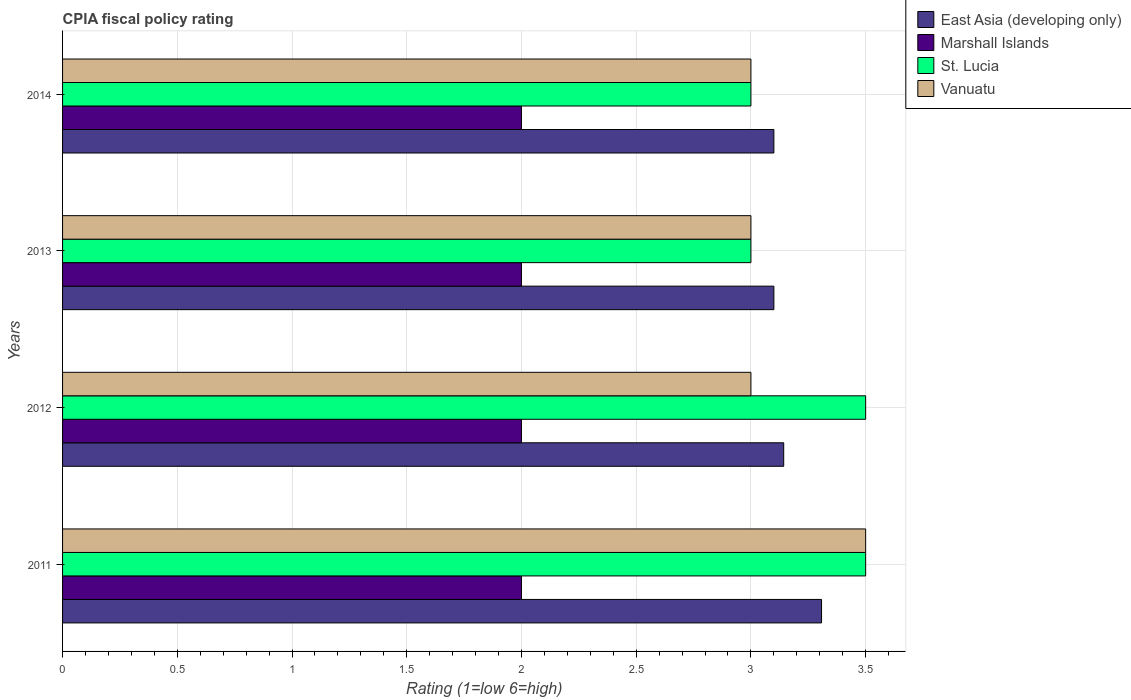How many groups of bars are there?
Your answer should be compact. 4. How many bars are there on the 2nd tick from the bottom?
Provide a short and direct response. 4. What is the label of the 1st group of bars from the top?
Your response must be concise. 2014. Across all years, what is the maximum CPIA rating in Vanuatu?
Your answer should be compact. 3.5. In which year was the CPIA rating in East Asia (developing only) maximum?
Offer a very short reply. 2011. What is the total CPIA rating in Vanuatu in the graph?
Make the answer very short. 12.5. What is the difference between the CPIA rating in Marshall Islands in 2013 and that in 2014?
Your response must be concise. 0. What is the average CPIA rating in East Asia (developing only) per year?
Provide a succinct answer. 3.16. In how many years, is the CPIA rating in East Asia (developing only) greater than 0.8 ?
Your answer should be very brief. 4. What is the ratio of the CPIA rating in St. Lucia in 2012 to that in 2014?
Your answer should be compact. 1.17. Is the CPIA rating in St. Lucia in 2011 less than that in 2013?
Give a very brief answer. No. Is the difference between the CPIA rating in Marshall Islands in 2012 and 2014 greater than the difference between the CPIA rating in Vanuatu in 2012 and 2014?
Keep it short and to the point. No. Is the sum of the CPIA rating in East Asia (developing only) in 2013 and 2014 greater than the maximum CPIA rating in Marshall Islands across all years?
Keep it short and to the point. Yes. Is it the case that in every year, the sum of the CPIA rating in East Asia (developing only) and CPIA rating in St. Lucia is greater than the sum of CPIA rating in Vanuatu and CPIA rating in Marshall Islands?
Provide a short and direct response. Yes. What does the 1st bar from the top in 2012 represents?
Your response must be concise. Vanuatu. What does the 4th bar from the bottom in 2014 represents?
Provide a short and direct response. Vanuatu. Is it the case that in every year, the sum of the CPIA rating in Marshall Islands and CPIA rating in East Asia (developing only) is greater than the CPIA rating in Vanuatu?
Offer a very short reply. Yes. How many bars are there?
Ensure brevity in your answer.  16. Are all the bars in the graph horizontal?
Make the answer very short. Yes. What is the difference between two consecutive major ticks on the X-axis?
Your answer should be very brief. 0.5. Does the graph contain any zero values?
Offer a very short reply. No. Does the graph contain grids?
Your answer should be very brief. Yes. How many legend labels are there?
Make the answer very short. 4. What is the title of the graph?
Your answer should be compact. CPIA fiscal policy rating. What is the label or title of the X-axis?
Provide a succinct answer. Rating (1=low 6=high). What is the Rating (1=low 6=high) in East Asia (developing only) in 2011?
Your response must be concise. 3.31. What is the Rating (1=low 6=high) of St. Lucia in 2011?
Give a very brief answer. 3.5. What is the Rating (1=low 6=high) of Vanuatu in 2011?
Offer a very short reply. 3.5. What is the Rating (1=low 6=high) of East Asia (developing only) in 2012?
Provide a short and direct response. 3.14. What is the Rating (1=low 6=high) in Marshall Islands in 2013?
Offer a very short reply. 2. What is the Rating (1=low 6=high) of Vanuatu in 2013?
Ensure brevity in your answer.  3. What is the Rating (1=low 6=high) of East Asia (developing only) in 2014?
Keep it short and to the point. 3.1. What is the Rating (1=low 6=high) in Marshall Islands in 2014?
Provide a succinct answer. 2. What is the Rating (1=low 6=high) in St. Lucia in 2014?
Give a very brief answer. 3. What is the Rating (1=low 6=high) in Vanuatu in 2014?
Your answer should be very brief. 3. Across all years, what is the maximum Rating (1=low 6=high) of East Asia (developing only)?
Offer a terse response. 3.31. Across all years, what is the maximum Rating (1=low 6=high) in Vanuatu?
Make the answer very short. 3.5. Across all years, what is the minimum Rating (1=low 6=high) of East Asia (developing only)?
Keep it short and to the point. 3.1. Across all years, what is the minimum Rating (1=low 6=high) of Marshall Islands?
Keep it short and to the point. 2. What is the total Rating (1=low 6=high) of East Asia (developing only) in the graph?
Give a very brief answer. 12.65. What is the difference between the Rating (1=low 6=high) in East Asia (developing only) in 2011 and that in 2012?
Offer a terse response. 0.16. What is the difference between the Rating (1=low 6=high) of Marshall Islands in 2011 and that in 2012?
Give a very brief answer. 0. What is the difference between the Rating (1=low 6=high) of St. Lucia in 2011 and that in 2012?
Offer a very short reply. 0. What is the difference between the Rating (1=low 6=high) of Vanuatu in 2011 and that in 2012?
Make the answer very short. 0.5. What is the difference between the Rating (1=low 6=high) in East Asia (developing only) in 2011 and that in 2013?
Your answer should be compact. 0.21. What is the difference between the Rating (1=low 6=high) of St. Lucia in 2011 and that in 2013?
Ensure brevity in your answer.  0.5. What is the difference between the Rating (1=low 6=high) of East Asia (developing only) in 2011 and that in 2014?
Give a very brief answer. 0.21. What is the difference between the Rating (1=low 6=high) in Marshall Islands in 2011 and that in 2014?
Provide a succinct answer. 0. What is the difference between the Rating (1=low 6=high) in East Asia (developing only) in 2012 and that in 2013?
Ensure brevity in your answer.  0.04. What is the difference between the Rating (1=low 6=high) in Vanuatu in 2012 and that in 2013?
Give a very brief answer. 0. What is the difference between the Rating (1=low 6=high) in East Asia (developing only) in 2012 and that in 2014?
Make the answer very short. 0.04. What is the difference between the Rating (1=low 6=high) of Vanuatu in 2012 and that in 2014?
Give a very brief answer. 0. What is the difference between the Rating (1=low 6=high) in Marshall Islands in 2013 and that in 2014?
Offer a very short reply. 0. What is the difference between the Rating (1=low 6=high) in St. Lucia in 2013 and that in 2014?
Your answer should be very brief. 0. What is the difference between the Rating (1=low 6=high) of East Asia (developing only) in 2011 and the Rating (1=low 6=high) of Marshall Islands in 2012?
Your answer should be compact. 1.31. What is the difference between the Rating (1=low 6=high) in East Asia (developing only) in 2011 and the Rating (1=low 6=high) in St. Lucia in 2012?
Make the answer very short. -0.19. What is the difference between the Rating (1=low 6=high) in East Asia (developing only) in 2011 and the Rating (1=low 6=high) in Vanuatu in 2012?
Your answer should be compact. 0.31. What is the difference between the Rating (1=low 6=high) of Marshall Islands in 2011 and the Rating (1=low 6=high) of St. Lucia in 2012?
Offer a terse response. -1.5. What is the difference between the Rating (1=low 6=high) in Marshall Islands in 2011 and the Rating (1=low 6=high) in Vanuatu in 2012?
Keep it short and to the point. -1. What is the difference between the Rating (1=low 6=high) of St. Lucia in 2011 and the Rating (1=low 6=high) of Vanuatu in 2012?
Offer a terse response. 0.5. What is the difference between the Rating (1=low 6=high) in East Asia (developing only) in 2011 and the Rating (1=low 6=high) in Marshall Islands in 2013?
Your answer should be very brief. 1.31. What is the difference between the Rating (1=low 6=high) of East Asia (developing only) in 2011 and the Rating (1=low 6=high) of St. Lucia in 2013?
Offer a very short reply. 0.31. What is the difference between the Rating (1=low 6=high) in East Asia (developing only) in 2011 and the Rating (1=low 6=high) in Vanuatu in 2013?
Offer a terse response. 0.31. What is the difference between the Rating (1=low 6=high) in East Asia (developing only) in 2011 and the Rating (1=low 6=high) in Marshall Islands in 2014?
Offer a very short reply. 1.31. What is the difference between the Rating (1=low 6=high) in East Asia (developing only) in 2011 and the Rating (1=low 6=high) in St. Lucia in 2014?
Offer a terse response. 0.31. What is the difference between the Rating (1=low 6=high) in East Asia (developing only) in 2011 and the Rating (1=low 6=high) in Vanuatu in 2014?
Give a very brief answer. 0.31. What is the difference between the Rating (1=low 6=high) of Marshall Islands in 2011 and the Rating (1=low 6=high) of Vanuatu in 2014?
Your response must be concise. -1. What is the difference between the Rating (1=low 6=high) of East Asia (developing only) in 2012 and the Rating (1=low 6=high) of St. Lucia in 2013?
Provide a short and direct response. 0.14. What is the difference between the Rating (1=low 6=high) in East Asia (developing only) in 2012 and the Rating (1=low 6=high) in Vanuatu in 2013?
Offer a terse response. 0.14. What is the difference between the Rating (1=low 6=high) of East Asia (developing only) in 2012 and the Rating (1=low 6=high) of Marshall Islands in 2014?
Ensure brevity in your answer.  1.14. What is the difference between the Rating (1=low 6=high) in East Asia (developing only) in 2012 and the Rating (1=low 6=high) in St. Lucia in 2014?
Provide a succinct answer. 0.14. What is the difference between the Rating (1=low 6=high) in East Asia (developing only) in 2012 and the Rating (1=low 6=high) in Vanuatu in 2014?
Give a very brief answer. 0.14. What is the difference between the Rating (1=low 6=high) in St. Lucia in 2012 and the Rating (1=low 6=high) in Vanuatu in 2014?
Ensure brevity in your answer.  0.5. What is the difference between the Rating (1=low 6=high) of East Asia (developing only) in 2013 and the Rating (1=low 6=high) of St. Lucia in 2014?
Your answer should be very brief. 0.1. What is the difference between the Rating (1=low 6=high) of Marshall Islands in 2013 and the Rating (1=low 6=high) of St. Lucia in 2014?
Offer a terse response. -1. What is the difference between the Rating (1=low 6=high) in St. Lucia in 2013 and the Rating (1=low 6=high) in Vanuatu in 2014?
Provide a short and direct response. 0. What is the average Rating (1=low 6=high) of East Asia (developing only) per year?
Ensure brevity in your answer.  3.16. What is the average Rating (1=low 6=high) in Vanuatu per year?
Keep it short and to the point. 3.12. In the year 2011, what is the difference between the Rating (1=low 6=high) in East Asia (developing only) and Rating (1=low 6=high) in Marshall Islands?
Offer a terse response. 1.31. In the year 2011, what is the difference between the Rating (1=low 6=high) of East Asia (developing only) and Rating (1=low 6=high) of St. Lucia?
Make the answer very short. -0.19. In the year 2011, what is the difference between the Rating (1=low 6=high) in East Asia (developing only) and Rating (1=low 6=high) in Vanuatu?
Ensure brevity in your answer.  -0.19. In the year 2011, what is the difference between the Rating (1=low 6=high) of Marshall Islands and Rating (1=low 6=high) of St. Lucia?
Give a very brief answer. -1.5. In the year 2011, what is the difference between the Rating (1=low 6=high) of Marshall Islands and Rating (1=low 6=high) of Vanuatu?
Your answer should be compact. -1.5. In the year 2012, what is the difference between the Rating (1=low 6=high) in East Asia (developing only) and Rating (1=low 6=high) in Marshall Islands?
Keep it short and to the point. 1.14. In the year 2012, what is the difference between the Rating (1=low 6=high) of East Asia (developing only) and Rating (1=low 6=high) of St. Lucia?
Provide a succinct answer. -0.36. In the year 2012, what is the difference between the Rating (1=low 6=high) of East Asia (developing only) and Rating (1=low 6=high) of Vanuatu?
Keep it short and to the point. 0.14. In the year 2012, what is the difference between the Rating (1=low 6=high) of Marshall Islands and Rating (1=low 6=high) of St. Lucia?
Your answer should be very brief. -1.5. In the year 2012, what is the difference between the Rating (1=low 6=high) in Marshall Islands and Rating (1=low 6=high) in Vanuatu?
Your answer should be very brief. -1. In the year 2013, what is the difference between the Rating (1=low 6=high) in East Asia (developing only) and Rating (1=low 6=high) in St. Lucia?
Give a very brief answer. 0.1. In the year 2013, what is the difference between the Rating (1=low 6=high) in Marshall Islands and Rating (1=low 6=high) in St. Lucia?
Ensure brevity in your answer.  -1. In the year 2014, what is the difference between the Rating (1=low 6=high) in East Asia (developing only) and Rating (1=low 6=high) in Marshall Islands?
Make the answer very short. 1.1. In the year 2014, what is the difference between the Rating (1=low 6=high) of East Asia (developing only) and Rating (1=low 6=high) of St. Lucia?
Give a very brief answer. 0.1. In the year 2014, what is the difference between the Rating (1=low 6=high) in East Asia (developing only) and Rating (1=low 6=high) in Vanuatu?
Your answer should be compact. 0.1. What is the ratio of the Rating (1=low 6=high) in East Asia (developing only) in 2011 to that in 2012?
Give a very brief answer. 1.05. What is the ratio of the Rating (1=low 6=high) of Marshall Islands in 2011 to that in 2012?
Keep it short and to the point. 1. What is the ratio of the Rating (1=low 6=high) in Vanuatu in 2011 to that in 2012?
Keep it short and to the point. 1.17. What is the ratio of the Rating (1=low 6=high) in East Asia (developing only) in 2011 to that in 2013?
Your answer should be compact. 1.07. What is the ratio of the Rating (1=low 6=high) in Marshall Islands in 2011 to that in 2013?
Provide a short and direct response. 1. What is the ratio of the Rating (1=low 6=high) of St. Lucia in 2011 to that in 2013?
Your answer should be compact. 1.17. What is the ratio of the Rating (1=low 6=high) in Vanuatu in 2011 to that in 2013?
Provide a succinct answer. 1.17. What is the ratio of the Rating (1=low 6=high) in East Asia (developing only) in 2011 to that in 2014?
Make the answer very short. 1.07. What is the ratio of the Rating (1=low 6=high) of St. Lucia in 2011 to that in 2014?
Your answer should be compact. 1.17. What is the ratio of the Rating (1=low 6=high) of East Asia (developing only) in 2012 to that in 2013?
Provide a succinct answer. 1.01. What is the ratio of the Rating (1=low 6=high) of Marshall Islands in 2012 to that in 2013?
Your answer should be compact. 1. What is the ratio of the Rating (1=low 6=high) of St. Lucia in 2012 to that in 2013?
Offer a very short reply. 1.17. What is the ratio of the Rating (1=low 6=high) of Vanuatu in 2012 to that in 2013?
Ensure brevity in your answer.  1. What is the ratio of the Rating (1=low 6=high) in East Asia (developing only) in 2012 to that in 2014?
Ensure brevity in your answer.  1.01. What is the ratio of the Rating (1=low 6=high) in Marshall Islands in 2012 to that in 2014?
Provide a short and direct response. 1. What is the ratio of the Rating (1=low 6=high) of St. Lucia in 2012 to that in 2014?
Offer a terse response. 1.17. What is the ratio of the Rating (1=low 6=high) in Vanuatu in 2012 to that in 2014?
Provide a succinct answer. 1. What is the ratio of the Rating (1=low 6=high) in East Asia (developing only) in 2013 to that in 2014?
Give a very brief answer. 1. What is the ratio of the Rating (1=low 6=high) of Vanuatu in 2013 to that in 2014?
Keep it short and to the point. 1. What is the difference between the highest and the second highest Rating (1=low 6=high) of East Asia (developing only)?
Your response must be concise. 0.16. What is the difference between the highest and the lowest Rating (1=low 6=high) in East Asia (developing only)?
Offer a terse response. 0.21. 